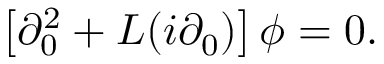<formula> <loc_0><loc_0><loc_500><loc_500>\left [ \partial _ { 0 } ^ { 2 } + L ( i \partial _ { 0 } ) \right ] \phi = 0 .</formula> 